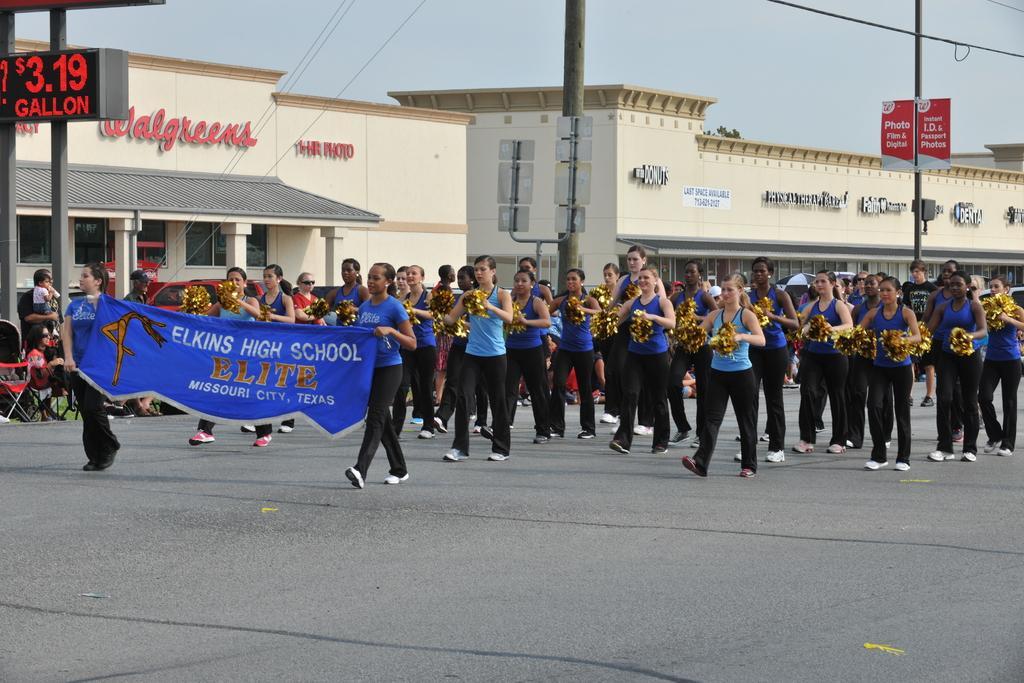Describe this image in one or two sentences. In this image I can see group of people. There are two persons holding a banner. There are buildings, poles, name boards, cables and in the background there is sky. 